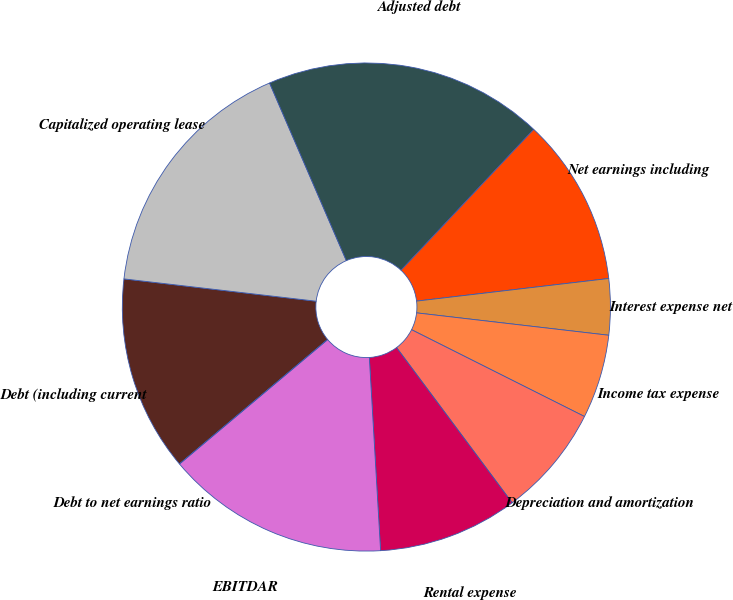<chart> <loc_0><loc_0><loc_500><loc_500><pie_chart><fcel>Debt (including current<fcel>Capitalized operating lease<fcel>Adjusted debt<fcel>Net earnings including<fcel>Interest expense net<fcel>Income tax expense<fcel>Depreciation and amortization<fcel>Rental expense<fcel>EBITDAR<fcel>Debt to net earnings ratio<nl><fcel>12.96%<fcel>16.67%<fcel>18.52%<fcel>11.11%<fcel>3.71%<fcel>5.56%<fcel>7.41%<fcel>9.26%<fcel>14.81%<fcel>0.0%<nl></chart> 